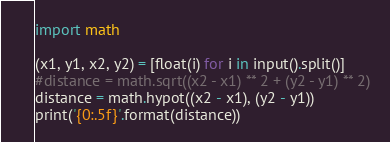Convert code to text. <code><loc_0><loc_0><loc_500><loc_500><_Python_>import math

(x1, y1, x2, y2) = [float(i) for i in input().split()]
#distance = math.sqrt((x2 - x1) ** 2 + (y2 - y1) ** 2)
distance = math.hypot((x2 - x1), (y2 - y1))
print('{0:.5f}'.format(distance))</code> 